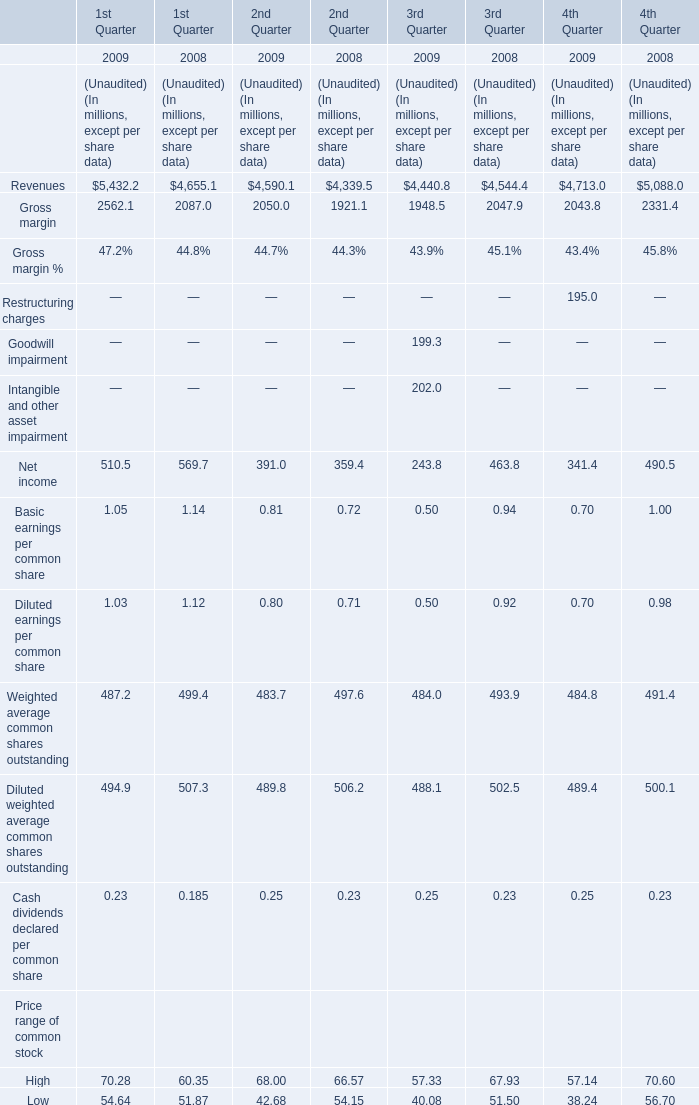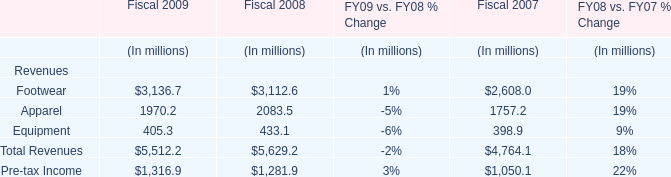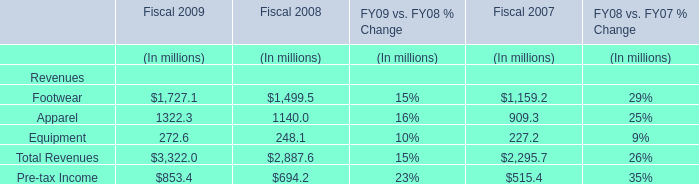Does the value of Revenues for 1st Quarter in 2008 greater than that in 2009? 
Answer: No. 